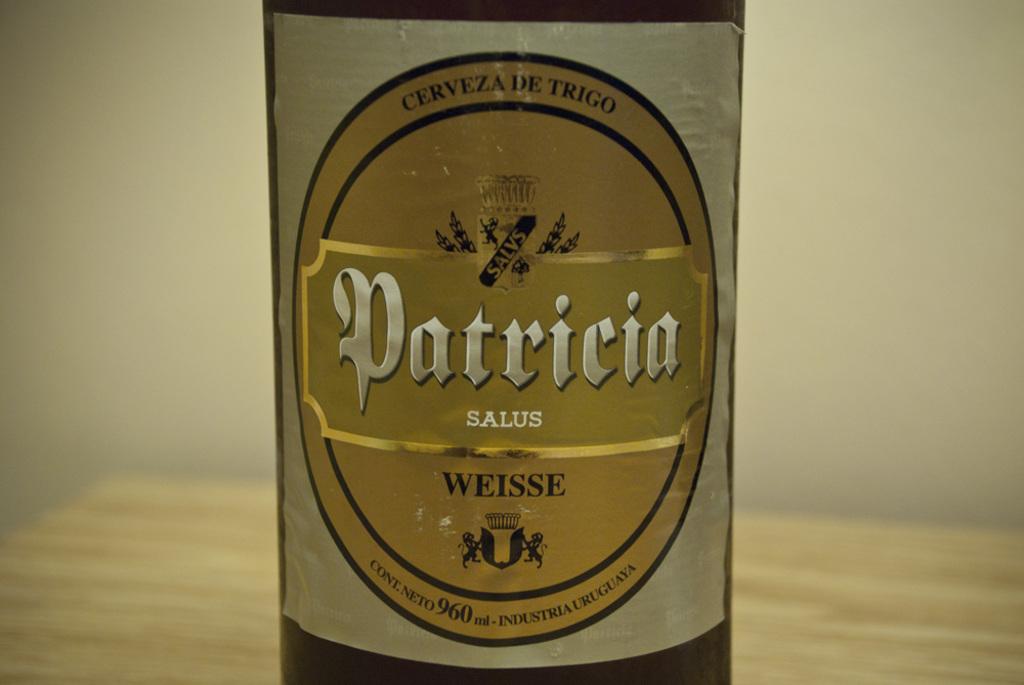What is the volume of the bottle?
Your answer should be compact. 960 ml. What name do we see on the bottle?
Ensure brevity in your answer.  Patricia. 